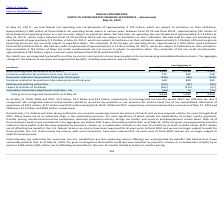Looking at Oracle Corporation's financial data, please calculate: What was the percentage change in "increases related to tax positions taken during current fiscal year" from 2017 to 2018? To answer this question, I need to perform calculations using the financial data. The calculation is: (840-595)/595 , which equals 41.18 (percentage). This is based on the information: "ositions taken during current fiscal year 540 840 595 ax positions taken during current fiscal year 540 840 595..." The key data points involved are: 595, 840. Also, can you calculate: What percentage of the gross unrecognized tax benefits as of June 1 in 2019 would affect the company's effective tax rate if recognised? Based on the calculation: 4.2 billion / 5,592 million , the result is 75.11 (percentage). This is based on the information: "Gross unrecognized tax benefits as of June 1 $ 5,592 $ 4,919 $ 4,561 As of May 31, 2019, 2018 and 2017, $4.2 billion, $4.2 billion and $3.4 billion, respectively, of unrecognized tax benefits would af..." The key data points involved are: 4.2, 5,592. Also, can you calculate: What was the total interest and penalties accrued as of May 31, 2019 and 2018 in millions? Based on the calculation: 1.3 billion + 992 million , the result is 2292 (in millions). This is based on the information: "nalties accrued as of May 31, 2019 and 2018 were $1.3 billion and $992 million, respectively. s of May 31, 2019 and 2018 were $1.3 billion and $992 million, respectively...." The key data points involved are: 1.3, 992. Also, Does oracle believe that the gross unrecognized tax benefits could decrease? We believe that it was reasonably possible that, as of May 31, 2019, the gross unrecognized tax benefits could decrease (whether by payment, release, or a combination of both) by as much as $186 million ($87 million net of offsetting tax benefits) in the next 12 months related primarily to transfer pricing. The document states: "returns affecting our unrecognized tax benefits. We believe that it was reasonably possible that, as of May 31, 2019, the gross unrecognized tax benef..." Also, What areas are being examined by the US federal and state taxing authorities, internationally and domestically? The document shows two values: Domestically, U.S. federal and state taxing authorities are currently examining income tax returns of Oracle and various acquired entities for years through fiscal 2017 and Internationally, tax authorities for numerous non-U.S. jurisdictions are also examining returns affecting our unrecognized tax benefits.. From the document: "Domestically, U.S. federal and state taxing authorities are currently examining income tax returns of Oracle and various acquired entities for years t..." Also, How does oracle classify its unrecognized tax benefits? We classify our unrecognized tax benefits as either current or non-current income taxes payable in the accompanying consolidated balance sheets. The document states: "We classify our unrecognized tax benefits as either current or non-current income taxes payable in the accompanying consolidated balance sheets. The a..." 